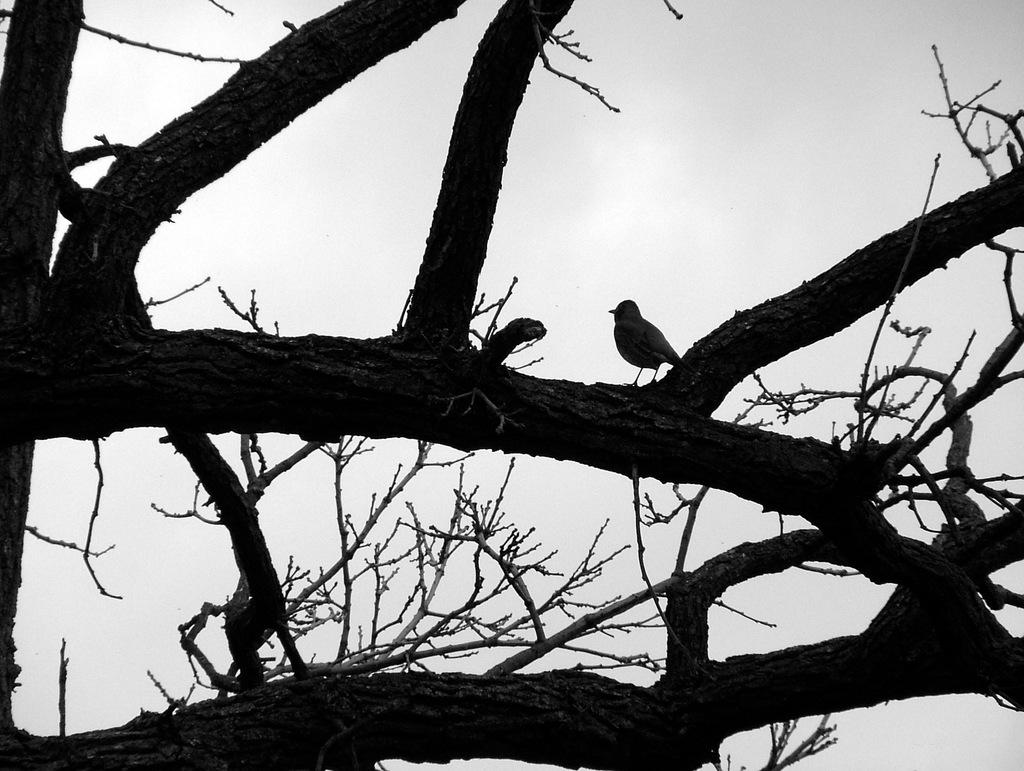What is the main object in the image? There is a tree in the image. Can you describe any living creatures in the image? A bird is present on a branch of the tree. What type of connection is the bird using to communicate with the tree? The bird does not need a connection to communicate with the tree, as they are both living organisms that can interact naturally. 